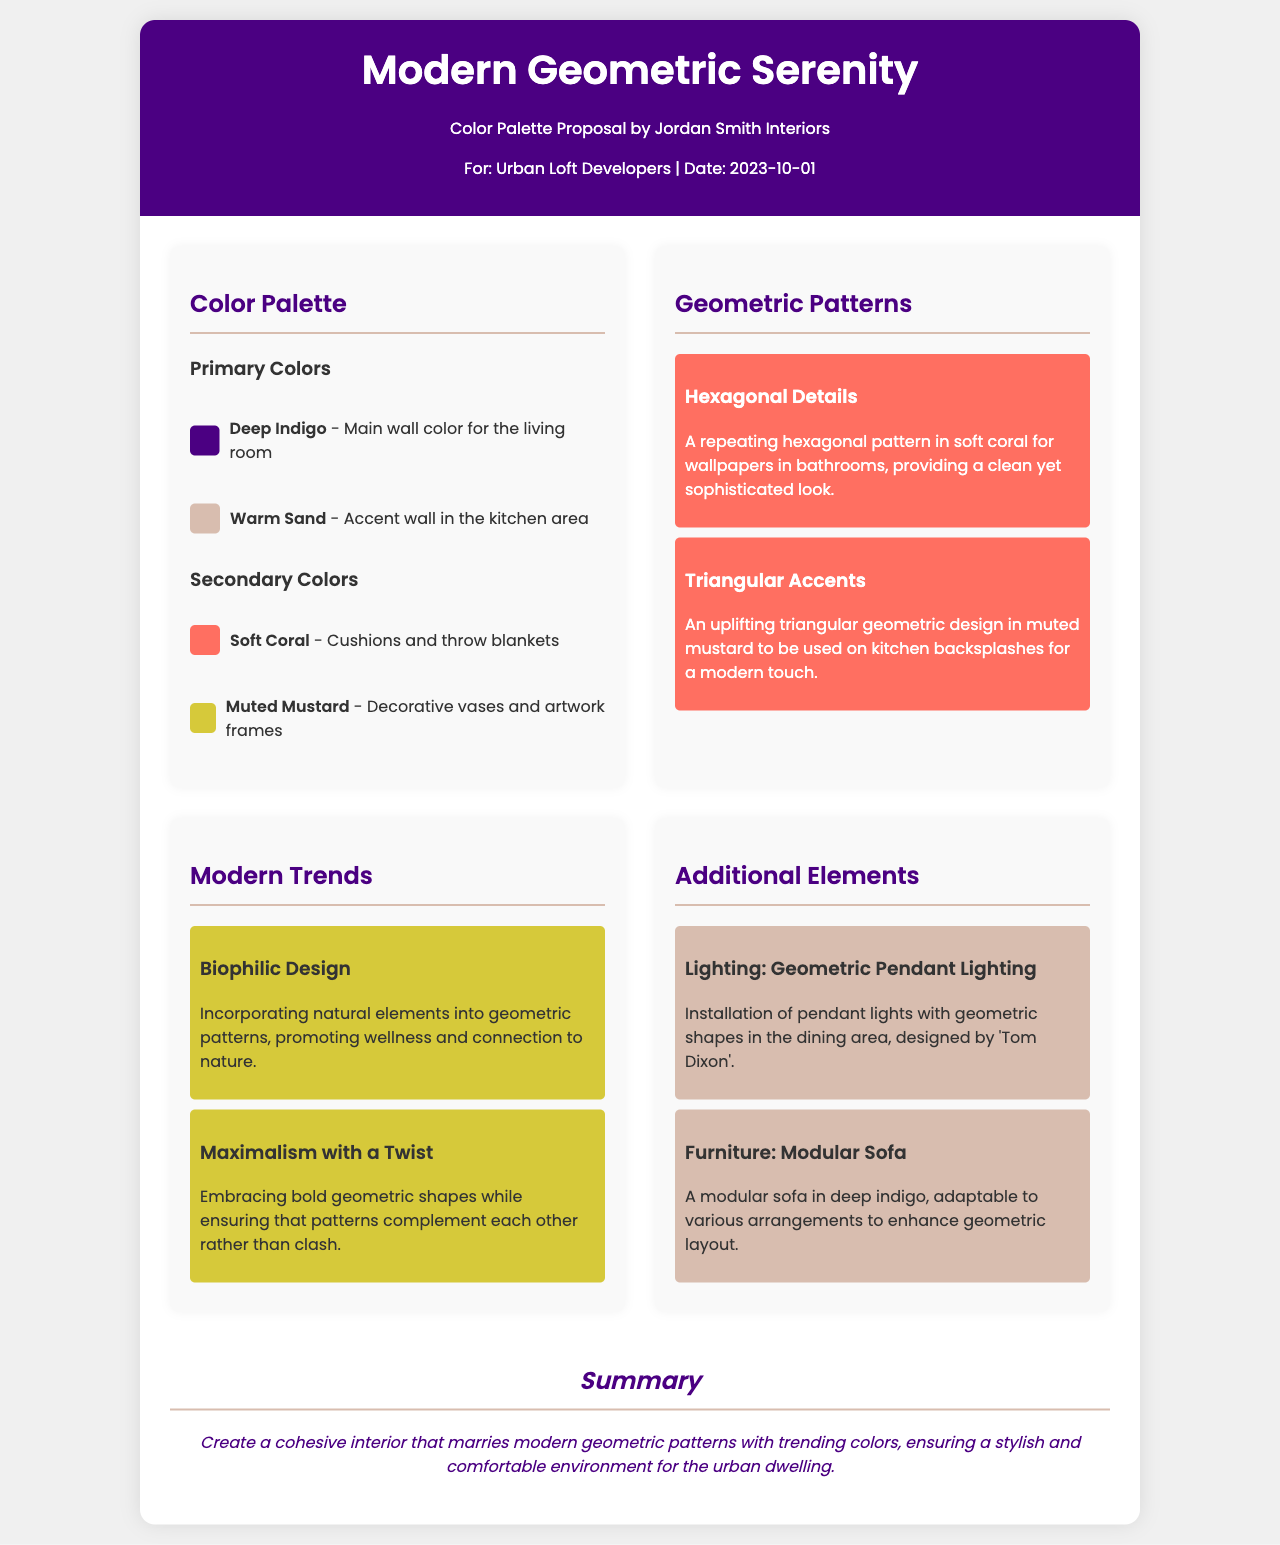What is the main title of the proposal? The title of the proposal is prominently displayed at the top of the document.
Answer: Modern Geometric Serenity Who authored the color palette proposal? The document credits the author prominently under the title.
Answer: Jordan Smith Interiors What is the date of the proposal? The date is mentioned under the author's information.
Answer: 2023-10-01 What is the primary color for the living room? The primary colors section provides details on specific color uses.
Answer: Deep Indigo Which geometric pattern is designed for bathroom wallpapers? The section on geometric patterns describes specific applications for each design.
Answer: Hexagonal Details How many secondary colors are listed in the palette? The document specifies the number of secondary colors under the colors section.
Answer: Two What modern trend emphasizes natural elements in design? The trends section provides insight into current design philosophies.
Answer: Biophilic Design What kind of pendant lighting is proposed for the dining area? The additional elements section describes specific features and their designs.
Answer: Geometric Pendant Lighting What color is the modular sofa? The color of the modular sofa is stated in the additional elements section.
Answer: Deep Indigo 